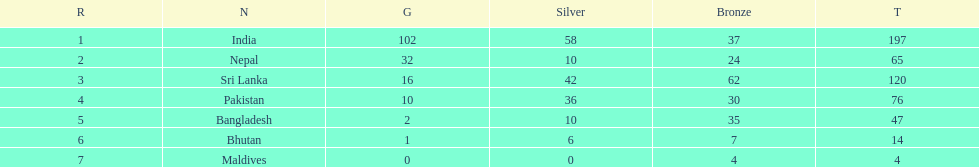What country has won no silver medals? Maldives. 